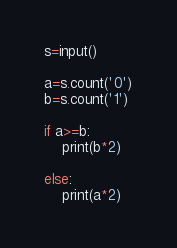<code> <loc_0><loc_0><loc_500><loc_500><_Python_>s=input()

a=s.count('0')
b=s.count('1')

if a>=b:
    print(b*2)

else:
    print(a*2)</code> 